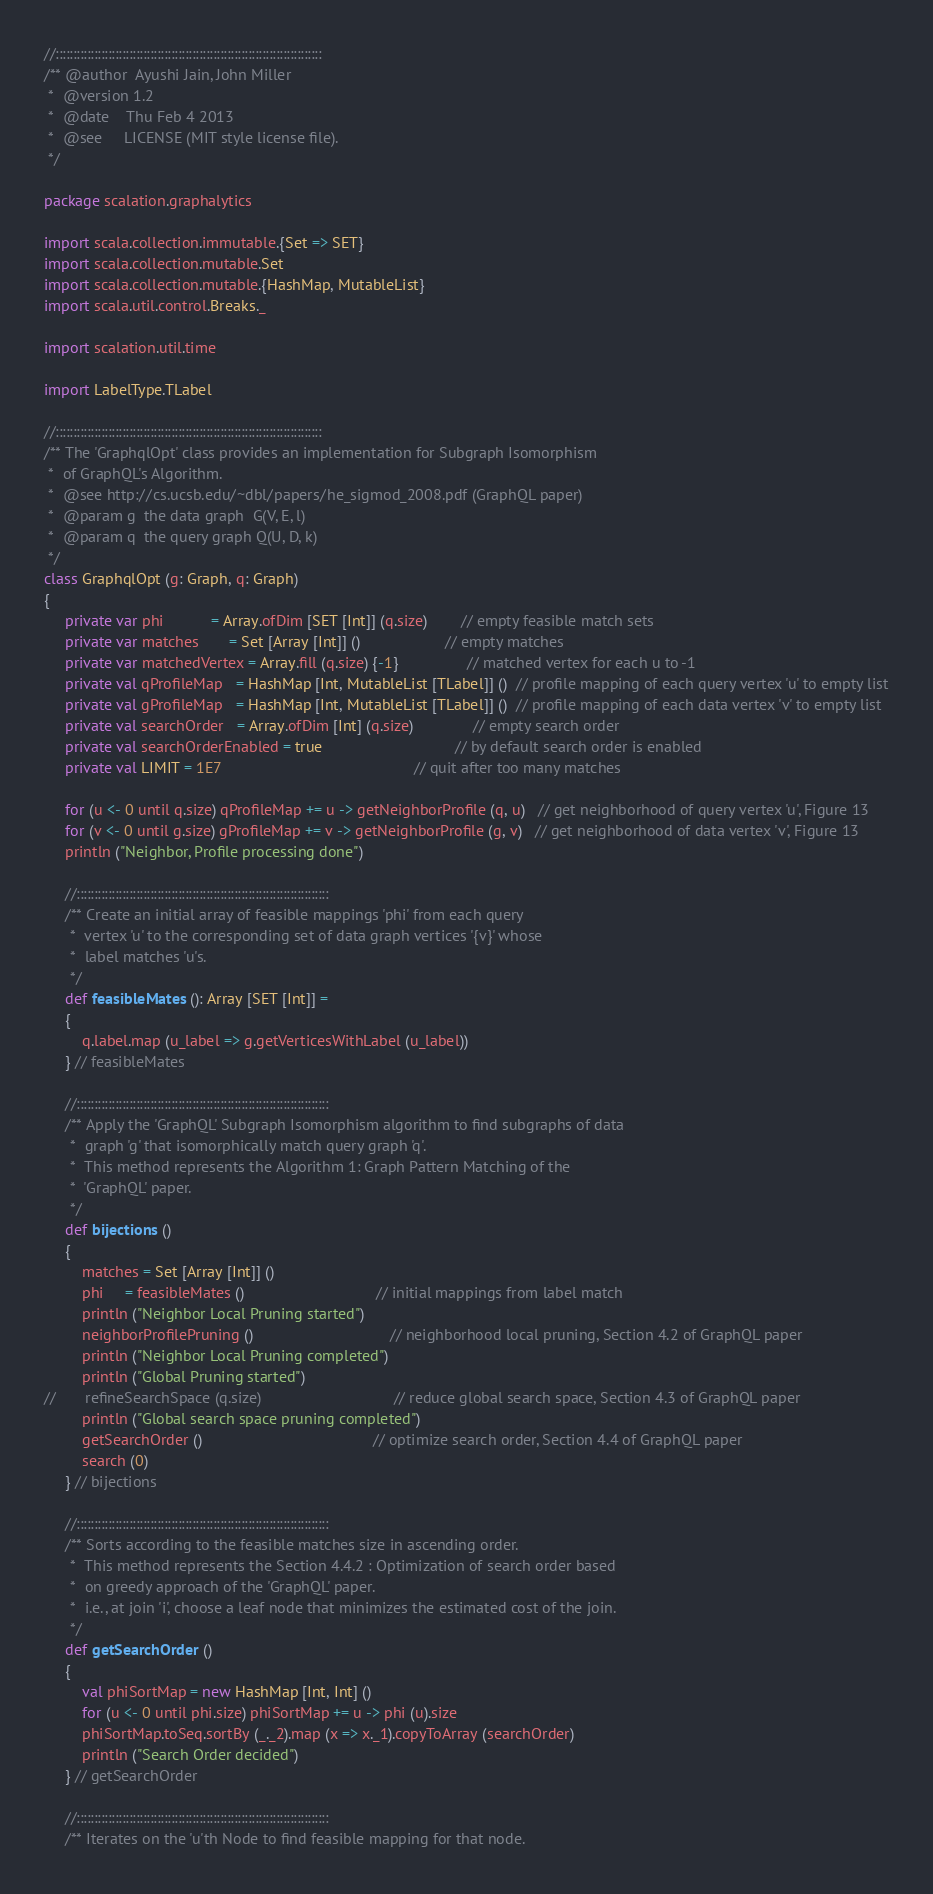<code> <loc_0><loc_0><loc_500><loc_500><_Scala_>
//::::::::::::::::::::::::::::::::::::::::::::::::::::::::::::::::::::::::::::
/** @author  Ayushi Jain, John Miller
 *  @version 1.2
 *  @date    Thu Feb 4 2013
 *  @see     LICENSE (MIT style license file).
 */

package scalation.graphalytics

import scala.collection.immutable.{Set => SET}
import scala.collection.mutable.Set
import scala.collection.mutable.{HashMap, MutableList}
import scala.util.control.Breaks._

import scalation.util.time

import LabelType.TLabel

//::::::::::::::::::::::::::::::::::::::::::::::::::::::::::::::::::::::::::::
/** The 'GraphqlOpt' class provides an implementation for Subgraph Isomorphism
 *  of GraphQL's Algorithm.
 *  @see http://cs.ucsb.edu/~dbl/papers/he_sigmod_2008.pdf (GraphQL paper)
 *  @param g  the data graph  G(V, E, l)
 *  @param q  the query graph Q(U, D, k)
 */
class GraphqlOpt (g: Graph, q: Graph) 
{
     private var phi           = Array.ofDim [SET [Int]] (q.size)        // empty feasible match sets
     private var matches       = Set [Array [Int]] ()                    // empty matches
     private var matchedVertex = Array.fill (q.size) {-1}                // matched vertex for each u to -1
     private val qProfileMap   = HashMap [Int, MutableList [TLabel]] ()  // profile mapping of each query vertex 'u' to empty list
     private val gProfileMap   = HashMap [Int, MutableList [TLabel]] ()  // profile mapping of each data vertex 'v' to empty list
     private val searchOrder   = Array.ofDim [Int] (q.size)              // empty search order
     private val searchOrderEnabled = true                               // by default search order is enabled
     private val LIMIT = 1E7                                             // quit after too many matches
   
     for (u <- 0 until q.size) qProfileMap += u -> getNeighborProfile (q, u)   // get neighborhood of query vertex 'u', Figure 13
     for (v <- 0 until g.size) gProfileMap += v -> getNeighborProfile (g, v)   // get neighborhood of data vertex 'v', Figure 13
     println ("Neighbor, Profile processing done")
   
     //::::::::::::::::::::::::::::::::::::::::::::::::::::::::::::::::::::::::
     /** Create an initial array of feasible mappings 'phi' from each query
      *  vertex 'u' to the corresponding set of data graph vertices '{v}' whose
      *  label matches 'u's.
      */
     def feasibleMates (): Array [SET [Int]] =
     {
         q.label.map (u_label => g.getVerticesWithLabel (u_label))
     } // feasibleMates

     //::::::::::::::::::::::::::::::::::::::::::::::::::::::::::::::::::::::::
     /** Apply the 'GraphQL' Subgraph Isomorphism algorithm to find subgraphs of data
      *  graph 'g' that isomorphically match query graph 'q'.  
      *  This method represents the Algorithm 1: Graph Pattern Matching of the
      *  'GraphQL' paper.
      */
     def bijections () 
     {
         matches = Set [Array [Int]] ()
         phi     = feasibleMates ()                               // initial mappings from label match
         println ("Neighbor Local Pruning started")
         neighborProfilePruning ()                                // neighborhood local pruning, Section 4.2 of GraphQL paper
         println ("Neighbor Local Pruning completed")
         println ("Global Pruning started")
//       refineSearchSpace (q.size)                               // reduce global search space, Section 4.3 of GraphQL paper
         println ("Global search space pruning completed")
         getSearchOrder ()                                        // optimize search order, Section 4.4 of GraphQL paper
         search (0)
     } // bijections
    
     //::::::::::::::::::::::::::::::::::::::::::::::::::::::::::::::::::::::::
     /** Sorts according to the feasible matches size in ascending order.
      *  This method represents the Section 4.4.2 : Optimization of search order based
      *  on greedy approach of the 'GraphQL' paper.
      *  i.e., at join 'i', choose a leaf node that minimizes the estimated cost of the join.
      */
     def getSearchOrder ()
     {
         val phiSortMap = new HashMap [Int, Int] ()
         for (u <- 0 until phi.size) phiSortMap += u -> phi (u).size
         phiSortMap.toSeq.sortBy (_._2).map (x => x._1).copyToArray (searchOrder)
         println ("Search Order decided")
     } // getSearchOrder
    
     //::::::::::::::::::::::::::::::::::::::::::::::::::::::::::::::::::::::::
     /** Iterates on the 'u'th Node to find feasible mapping for that node.</code> 